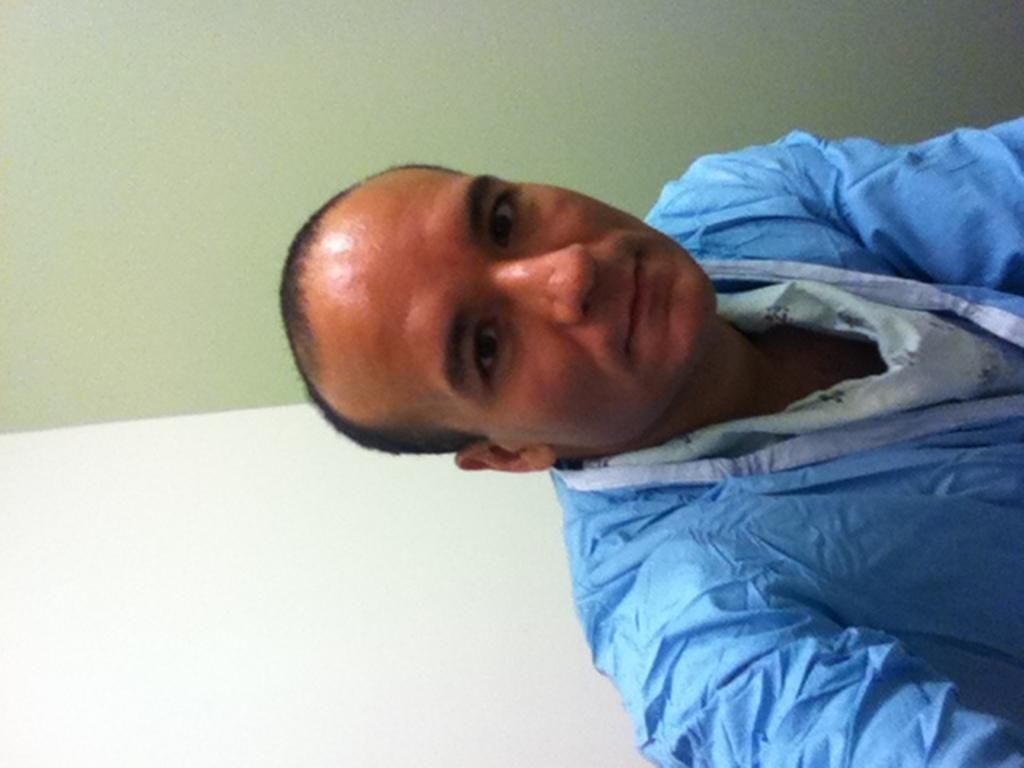Who is present in the image? There is a man in the image. What is the man wearing? The man is wearing a blue dress. What can be seen in the background of the image? There is a wall in the background of the image. What colors are used for the wall? The wall is in white and green colors. What type of marble is the man eating for breakfast in the image? There is no marble or breakfast present in the image. The man is wearing a blue dress, and there is a wall in the background. 